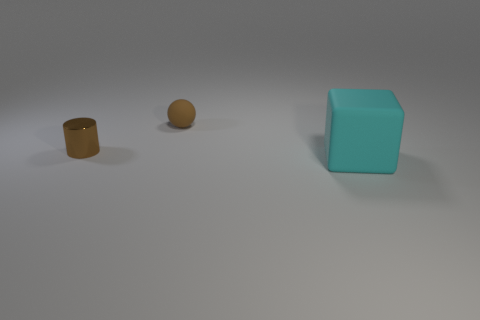Is the number of small shiny cylinders that are in front of the cyan object the same as the number of big cubes?
Your answer should be very brief. No. What size is the brown thing to the left of the small brown rubber thing?
Your answer should be compact. Small. What is the object that is both to the left of the big matte cube and on the right side of the small metallic object made of?
Provide a short and direct response. Rubber. Do the big cyan thing and the tiny cylinder have the same material?
Keep it short and to the point. No. What number of large red matte balls are there?
Provide a short and direct response. 0. There is a matte object behind the small brown thing that is on the left side of the matte thing that is to the left of the large matte object; what is its color?
Offer a very short reply. Brown. Does the cylinder have the same color as the small rubber ball?
Give a very brief answer. Yes. What number of objects are both right of the tiny brown cylinder and to the left of the big cyan matte thing?
Your answer should be compact. 1. What number of metal objects are either red objects or tiny cylinders?
Offer a terse response. 1. What material is the object that is right of the rubber object behind the brown cylinder made of?
Give a very brief answer. Rubber. 